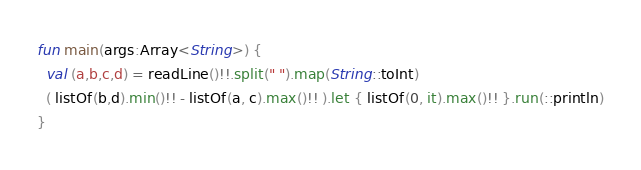<code> <loc_0><loc_0><loc_500><loc_500><_Kotlin_>fun main(args:Array<String>) {
  val (a,b,c,d) = readLine()!!.split(" ").map(String::toInt)
  ( listOf(b,d).min()!! - listOf(a, c).max()!! ).let { listOf(0, it).max()!! }.run(::println)
}
</code> 